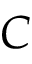Convert formula to latex. <formula><loc_0><loc_0><loc_500><loc_500>C</formula> 